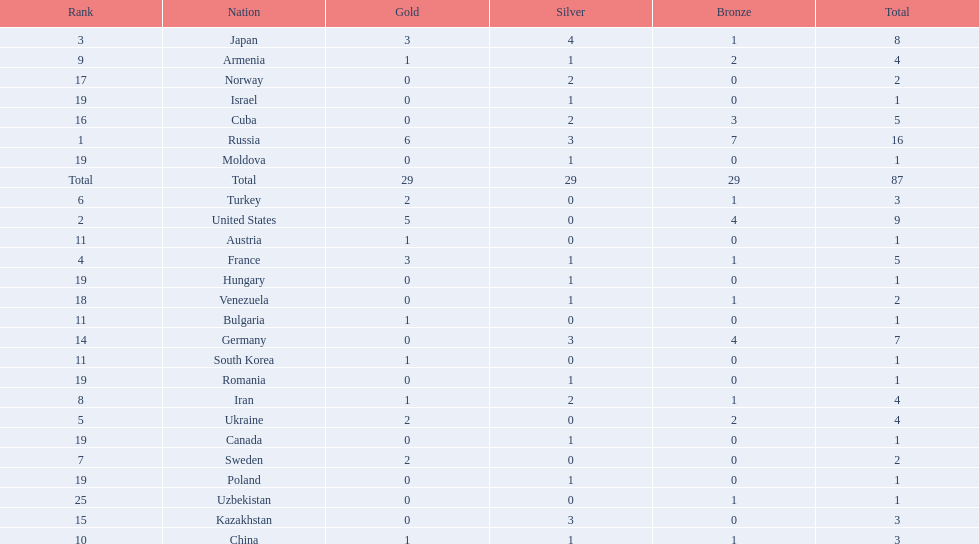Which nations have gold medals? Russia, United States, Japan, France, Ukraine, Turkey, Sweden, Iran, Armenia, China, Austria, Bulgaria, South Korea. Of those nations, which have only one gold medal? Iran, Armenia, China, Austria, Bulgaria, South Korea. Of those nations, which has no bronze or silver medals? Austria. 